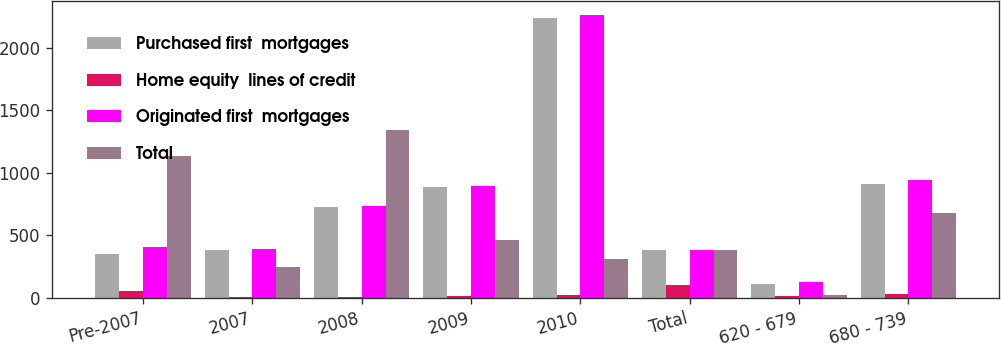Convert chart to OTSL. <chart><loc_0><loc_0><loc_500><loc_500><stacked_bar_chart><ecel><fcel>Pre-2007<fcel>2007<fcel>2008<fcel>2009<fcel>2010<fcel>Total<fcel>620 - 679<fcel>680 - 739<nl><fcel>Purchased first  mortgages<fcel>352<fcel>384<fcel>728<fcel>884<fcel>2240<fcel>384<fcel>115<fcel>907<nl><fcel>Home equity  lines of credit<fcel>58<fcel>9<fcel>8<fcel>12<fcel>20<fcel>107<fcel>15<fcel>33<nl><fcel>Originated first  mortgages<fcel>410<fcel>393<fcel>736<fcel>896<fcel>2260<fcel>384<fcel>130<fcel>940<nl><fcel>Total<fcel>1132<fcel>245<fcel>1345<fcel>466<fcel>312<fcel>384<fcel>26<fcel>677<nl></chart> 